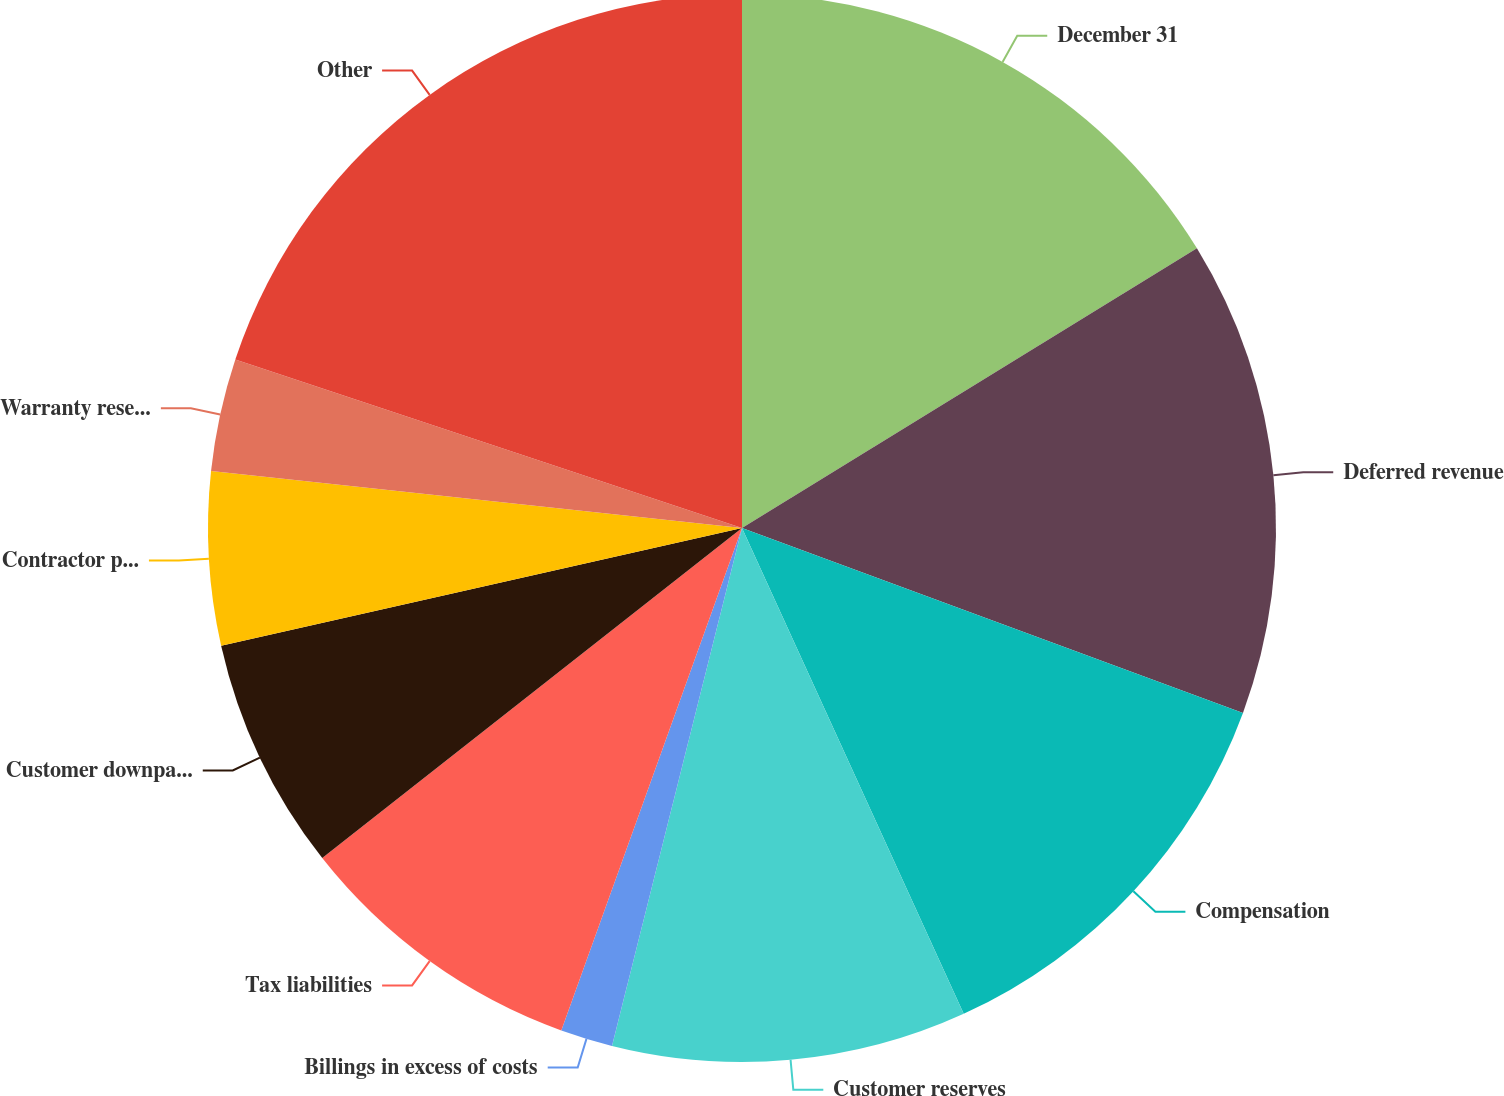Convert chart to OTSL. <chart><loc_0><loc_0><loc_500><loc_500><pie_chart><fcel>December 31<fcel>Deferred revenue<fcel>Compensation<fcel>Customer reserves<fcel>Billings in excess of costs<fcel>Tax liabilities<fcel>Customer downpayments<fcel>Contractor payables<fcel>Warranty reserves<fcel>Other<nl><fcel>16.23%<fcel>14.4%<fcel>12.56%<fcel>10.73%<fcel>1.58%<fcel>8.9%<fcel>7.07%<fcel>5.24%<fcel>3.41%<fcel>19.89%<nl></chart> 